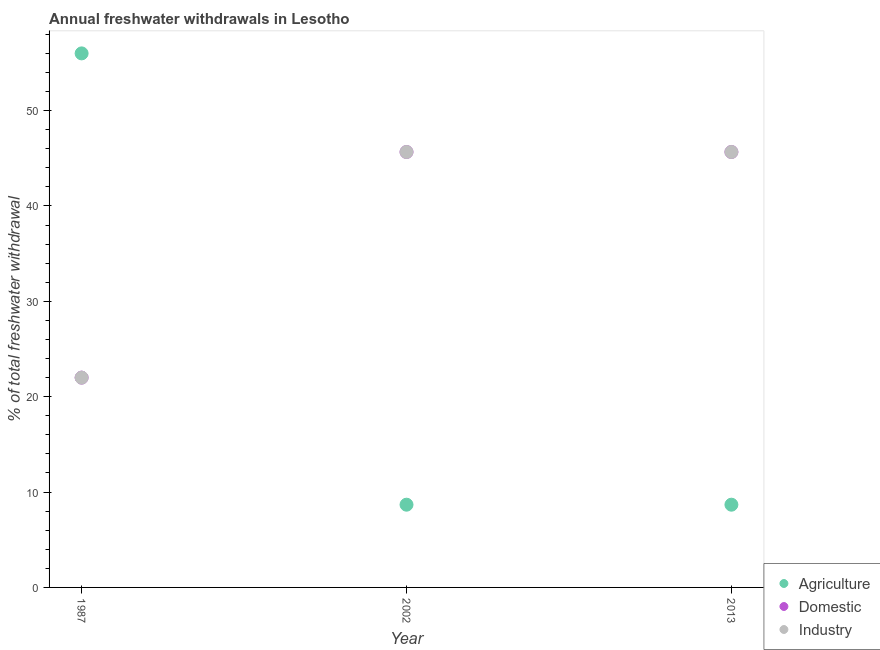What is the percentage of freshwater withdrawal for domestic purposes in 2002?
Provide a succinct answer. 45.66. Across all years, what is the maximum percentage of freshwater withdrawal for domestic purposes?
Provide a short and direct response. 45.66. In which year was the percentage of freshwater withdrawal for domestic purposes minimum?
Give a very brief answer. 1987. What is the total percentage of freshwater withdrawal for agriculture in the graph?
Provide a short and direct response. 73.35. What is the difference between the percentage of freshwater withdrawal for industry in 2013 and the percentage of freshwater withdrawal for domestic purposes in 2002?
Make the answer very short. 0. What is the average percentage of freshwater withdrawal for agriculture per year?
Give a very brief answer. 24.45. What is the ratio of the percentage of freshwater withdrawal for domestic purposes in 2002 to that in 2013?
Your answer should be very brief. 1. Is the percentage of freshwater withdrawal for agriculture in 1987 less than that in 2013?
Your answer should be compact. No. What is the difference between the highest and the second highest percentage of freshwater withdrawal for agriculture?
Your response must be concise. 47.32. What is the difference between the highest and the lowest percentage of freshwater withdrawal for domestic purposes?
Give a very brief answer. 23.66. In how many years, is the percentage of freshwater withdrawal for agriculture greater than the average percentage of freshwater withdrawal for agriculture taken over all years?
Your answer should be compact. 1. Does the percentage of freshwater withdrawal for agriculture monotonically increase over the years?
Offer a very short reply. No. Is the percentage of freshwater withdrawal for domestic purposes strictly greater than the percentage of freshwater withdrawal for industry over the years?
Give a very brief answer. No. How many dotlines are there?
Offer a terse response. 3. How many years are there in the graph?
Provide a short and direct response. 3. Does the graph contain any zero values?
Your answer should be compact. No. Does the graph contain grids?
Your answer should be compact. No. What is the title of the graph?
Keep it short and to the point. Annual freshwater withdrawals in Lesotho. What is the label or title of the X-axis?
Offer a terse response. Year. What is the label or title of the Y-axis?
Your response must be concise. % of total freshwater withdrawal. What is the % of total freshwater withdrawal of Agriculture in 1987?
Offer a terse response. 56. What is the % of total freshwater withdrawal in Domestic in 1987?
Offer a terse response. 22. What is the % of total freshwater withdrawal in Agriculture in 2002?
Ensure brevity in your answer.  8.68. What is the % of total freshwater withdrawal in Domestic in 2002?
Keep it short and to the point. 45.66. What is the % of total freshwater withdrawal in Industry in 2002?
Provide a short and direct response. 45.66. What is the % of total freshwater withdrawal of Agriculture in 2013?
Your answer should be very brief. 8.68. What is the % of total freshwater withdrawal in Domestic in 2013?
Offer a very short reply. 45.66. What is the % of total freshwater withdrawal of Industry in 2013?
Offer a terse response. 45.66. Across all years, what is the maximum % of total freshwater withdrawal in Domestic?
Ensure brevity in your answer.  45.66. Across all years, what is the maximum % of total freshwater withdrawal of Industry?
Give a very brief answer. 45.66. Across all years, what is the minimum % of total freshwater withdrawal in Agriculture?
Keep it short and to the point. 8.68. What is the total % of total freshwater withdrawal in Agriculture in the graph?
Keep it short and to the point. 73.35. What is the total % of total freshwater withdrawal in Domestic in the graph?
Provide a succinct answer. 113.32. What is the total % of total freshwater withdrawal of Industry in the graph?
Your response must be concise. 113.32. What is the difference between the % of total freshwater withdrawal of Agriculture in 1987 and that in 2002?
Give a very brief answer. 47.32. What is the difference between the % of total freshwater withdrawal of Domestic in 1987 and that in 2002?
Your response must be concise. -23.66. What is the difference between the % of total freshwater withdrawal in Industry in 1987 and that in 2002?
Ensure brevity in your answer.  -23.66. What is the difference between the % of total freshwater withdrawal of Agriculture in 1987 and that in 2013?
Make the answer very short. 47.32. What is the difference between the % of total freshwater withdrawal in Domestic in 1987 and that in 2013?
Ensure brevity in your answer.  -23.66. What is the difference between the % of total freshwater withdrawal in Industry in 1987 and that in 2013?
Make the answer very short. -23.66. What is the difference between the % of total freshwater withdrawal in Agriculture in 2002 and that in 2013?
Provide a succinct answer. 0. What is the difference between the % of total freshwater withdrawal in Domestic in 2002 and that in 2013?
Offer a terse response. 0. What is the difference between the % of total freshwater withdrawal of Agriculture in 1987 and the % of total freshwater withdrawal of Domestic in 2002?
Offer a very short reply. 10.34. What is the difference between the % of total freshwater withdrawal of Agriculture in 1987 and the % of total freshwater withdrawal of Industry in 2002?
Your answer should be compact. 10.34. What is the difference between the % of total freshwater withdrawal in Domestic in 1987 and the % of total freshwater withdrawal in Industry in 2002?
Your response must be concise. -23.66. What is the difference between the % of total freshwater withdrawal in Agriculture in 1987 and the % of total freshwater withdrawal in Domestic in 2013?
Your answer should be very brief. 10.34. What is the difference between the % of total freshwater withdrawal in Agriculture in 1987 and the % of total freshwater withdrawal in Industry in 2013?
Provide a succinct answer. 10.34. What is the difference between the % of total freshwater withdrawal in Domestic in 1987 and the % of total freshwater withdrawal in Industry in 2013?
Provide a short and direct response. -23.66. What is the difference between the % of total freshwater withdrawal in Agriculture in 2002 and the % of total freshwater withdrawal in Domestic in 2013?
Give a very brief answer. -36.98. What is the difference between the % of total freshwater withdrawal in Agriculture in 2002 and the % of total freshwater withdrawal in Industry in 2013?
Give a very brief answer. -36.98. What is the difference between the % of total freshwater withdrawal in Domestic in 2002 and the % of total freshwater withdrawal in Industry in 2013?
Your response must be concise. 0. What is the average % of total freshwater withdrawal in Agriculture per year?
Ensure brevity in your answer.  24.45. What is the average % of total freshwater withdrawal of Domestic per year?
Give a very brief answer. 37.77. What is the average % of total freshwater withdrawal of Industry per year?
Provide a short and direct response. 37.77. In the year 2002, what is the difference between the % of total freshwater withdrawal in Agriculture and % of total freshwater withdrawal in Domestic?
Give a very brief answer. -36.98. In the year 2002, what is the difference between the % of total freshwater withdrawal of Agriculture and % of total freshwater withdrawal of Industry?
Give a very brief answer. -36.98. In the year 2013, what is the difference between the % of total freshwater withdrawal in Agriculture and % of total freshwater withdrawal in Domestic?
Keep it short and to the point. -36.98. In the year 2013, what is the difference between the % of total freshwater withdrawal of Agriculture and % of total freshwater withdrawal of Industry?
Offer a very short reply. -36.98. What is the ratio of the % of total freshwater withdrawal in Agriculture in 1987 to that in 2002?
Your answer should be very brief. 6.45. What is the ratio of the % of total freshwater withdrawal of Domestic in 1987 to that in 2002?
Keep it short and to the point. 0.48. What is the ratio of the % of total freshwater withdrawal of Industry in 1987 to that in 2002?
Your response must be concise. 0.48. What is the ratio of the % of total freshwater withdrawal of Agriculture in 1987 to that in 2013?
Your response must be concise. 6.45. What is the ratio of the % of total freshwater withdrawal of Domestic in 1987 to that in 2013?
Make the answer very short. 0.48. What is the ratio of the % of total freshwater withdrawal in Industry in 1987 to that in 2013?
Ensure brevity in your answer.  0.48. What is the ratio of the % of total freshwater withdrawal in Agriculture in 2002 to that in 2013?
Offer a very short reply. 1. What is the ratio of the % of total freshwater withdrawal in Domestic in 2002 to that in 2013?
Your answer should be compact. 1. What is the difference between the highest and the second highest % of total freshwater withdrawal of Agriculture?
Your response must be concise. 47.32. What is the difference between the highest and the second highest % of total freshwater withdrawal of Domestic?
Ensure brevity in your answer.  0. What is the difference between the highest and the second highest % of total freshwater withdrawal of Industry?
Give a very brief answer. 0. What is the difference between the highest and the lowest % of total freshwater withdrawal in Agriculture?
Your answer should be very brief. 47.32. What is the difference between the highest and the lowest % of total freshwater withdrawal in Domestic?
Provide a succinct answer. 23.66. What is the difference between the highest and the lowest % of total freshwater withdrawal of Industry?
Your answer should be very brief. 23.66. 